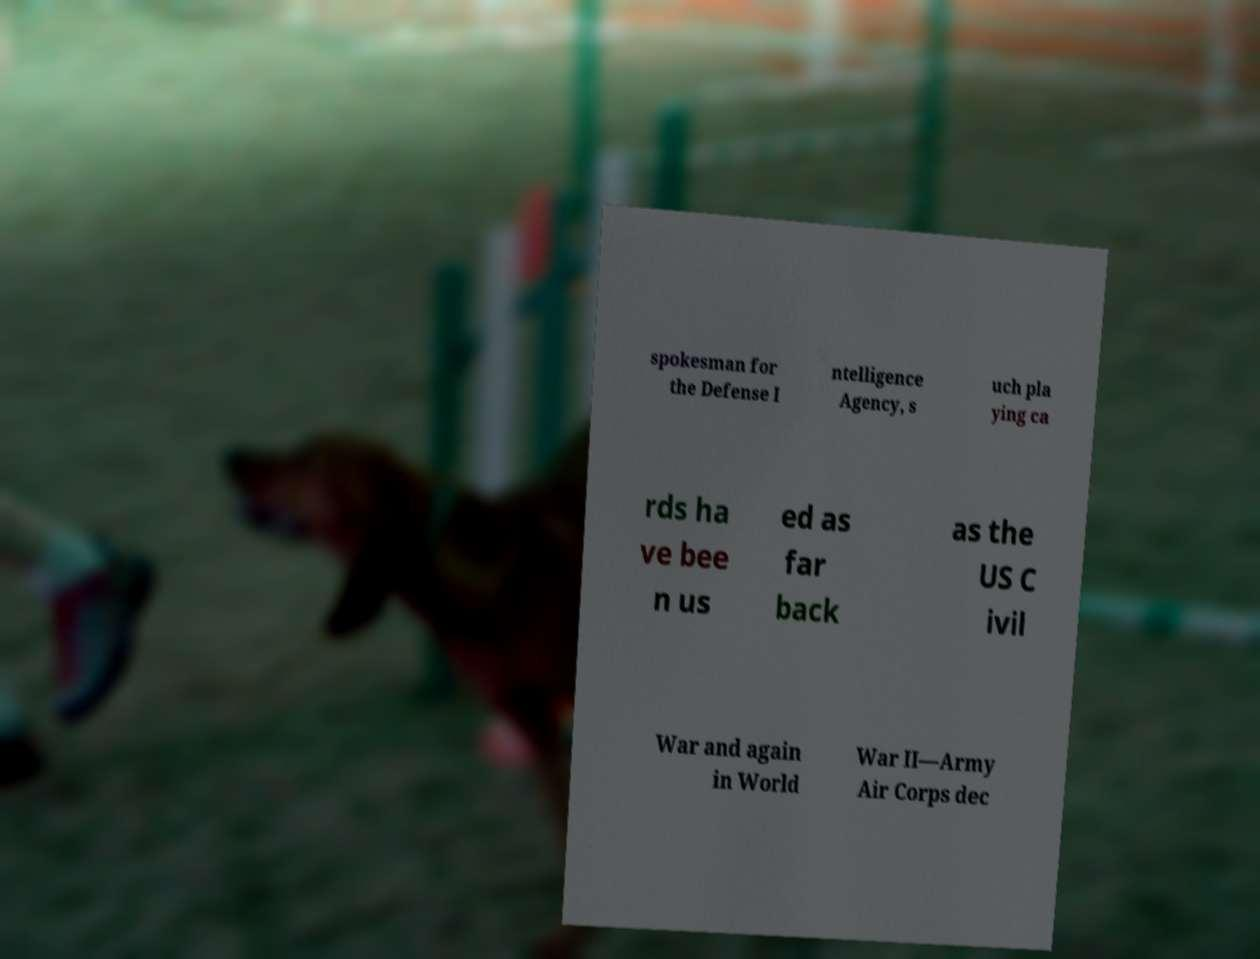Could you assist in decoding the text presented in this image and type it out clearly? spokesman for the Defense I ntelligence Agency, s uch pla ying ca rds ha ve bee n us ed as far back as the US C ivil War and again in World War II—Army Air Corps dec 